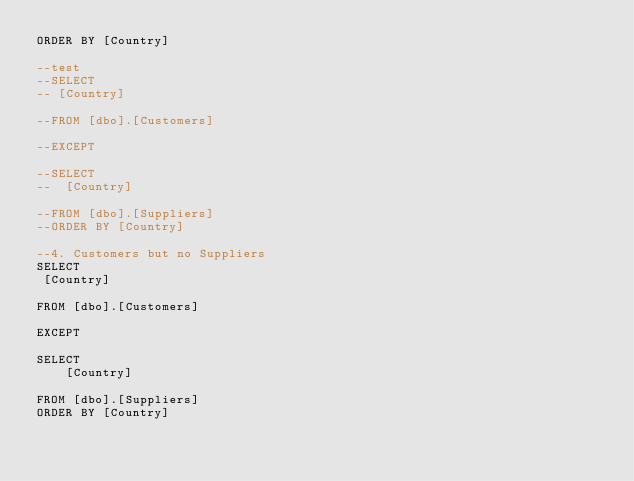Convert code to text. <code><loc_0><loc_0><loc_500><loc_500><_SQL_>ORDER BY [Country]

--test
--SELECT
-- [Country]

--FROM [dbo].[Customers]

--EXCEPT

--SELECT
--	[Country]

--FROM [dbo].[Suppliers]
--ORDER BY [Country]

--4. Customers but no Suppliers
SELECT
 [Country]

FROM [dbo].[Customers]

EXCEPT

SELECT
	[Country]

FROM [dbo].[Suppliers]
ORDER BY [Country]
</code> 